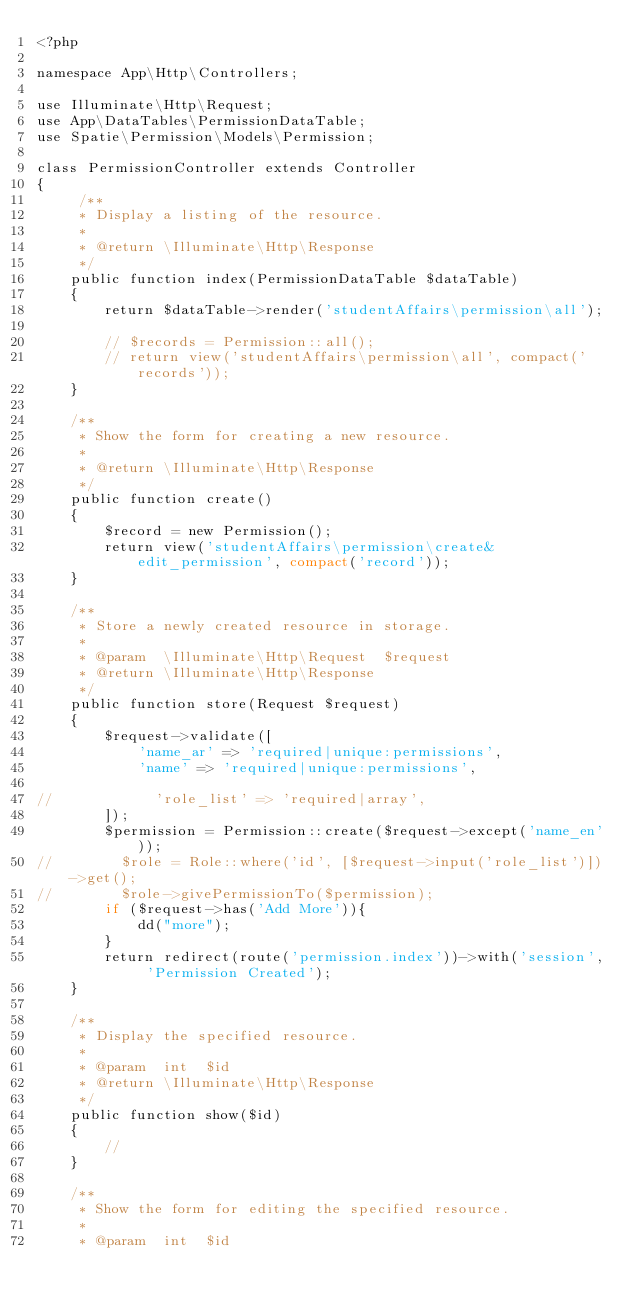<code> <loc_0><loc_0><loc_500><loc_500><_PHP_><?php

namespace App\Http\Controllers;

use Illuminate\Http\Request;
use App\DataTables\PermissionDataTable;
use Spatie\Permission\Models\Permission;

class PermissionController extends Controller
{
     /**
     * Display a listing of the resource.
     *
     * @return \Illuminate\Http\Response
     */
    public function index(PermissionDataTable $dataTable)
    {
        return $dataTable->render('studentAffairs\permission\all');

        // $records = Permission::all();
        // return view('studentAffairs\permission\all', compact('records'));
    }

    /**
     * Show the form for creating a new resource.
     *
     * @return \Illuminate\Http\Response
     */
    public function create()
    {
        $record = new Permission();
        return view('studentAffairs\permission\create&edit_permission', compact('record'));
    }

    /**
     * Store a newly created resource in storage.
     *
     * @param  \Illuminate\Http\Request  $request
     * @return \Illuminate\Http\Response
     */
    public function store(Request $request)
    {
        $request->validate([
            'name_ar' => 'required|unique:permissions',
            'name' => 'required|unique:permissions',

//            'role_list' => 'required|array',
        ]);
        $permission = Permission::create($request->except('name_en'));
//        $role = Role::where('id', [$request->input('role_list')])->get();
//        $role->givePermissionTo($permission);
        if ($request->has('Add More')){
            dd("more");
        }
        return redirect(route('permission.index'))->with('session', 'Permission Created');
    }

    /**
     * Display the specified resource.
     *
     * @param  int  $id
     * @return \Illuminate\Http\Response
     */
    public function show($id)
    {
        //
    }

    /**
     * Show the form for editing the specified resource.
     *
     * @param  int  $id</code> 